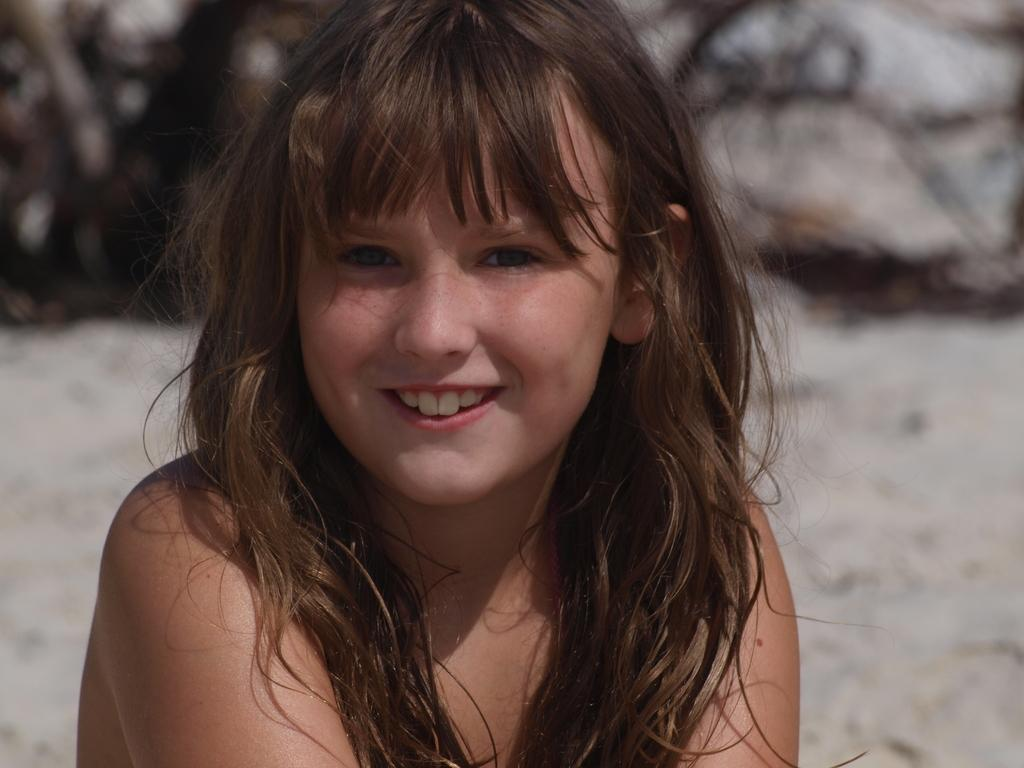Who is the main subject in the image? There is a woman in the front of the image. What can be seen in the background of the image? There are rocks in the background of the image. How would you describe the background in the image? The background is slightly blurred. How many toads are sitting on the woman's cap in the image? There are no toads or caps present in the image. 